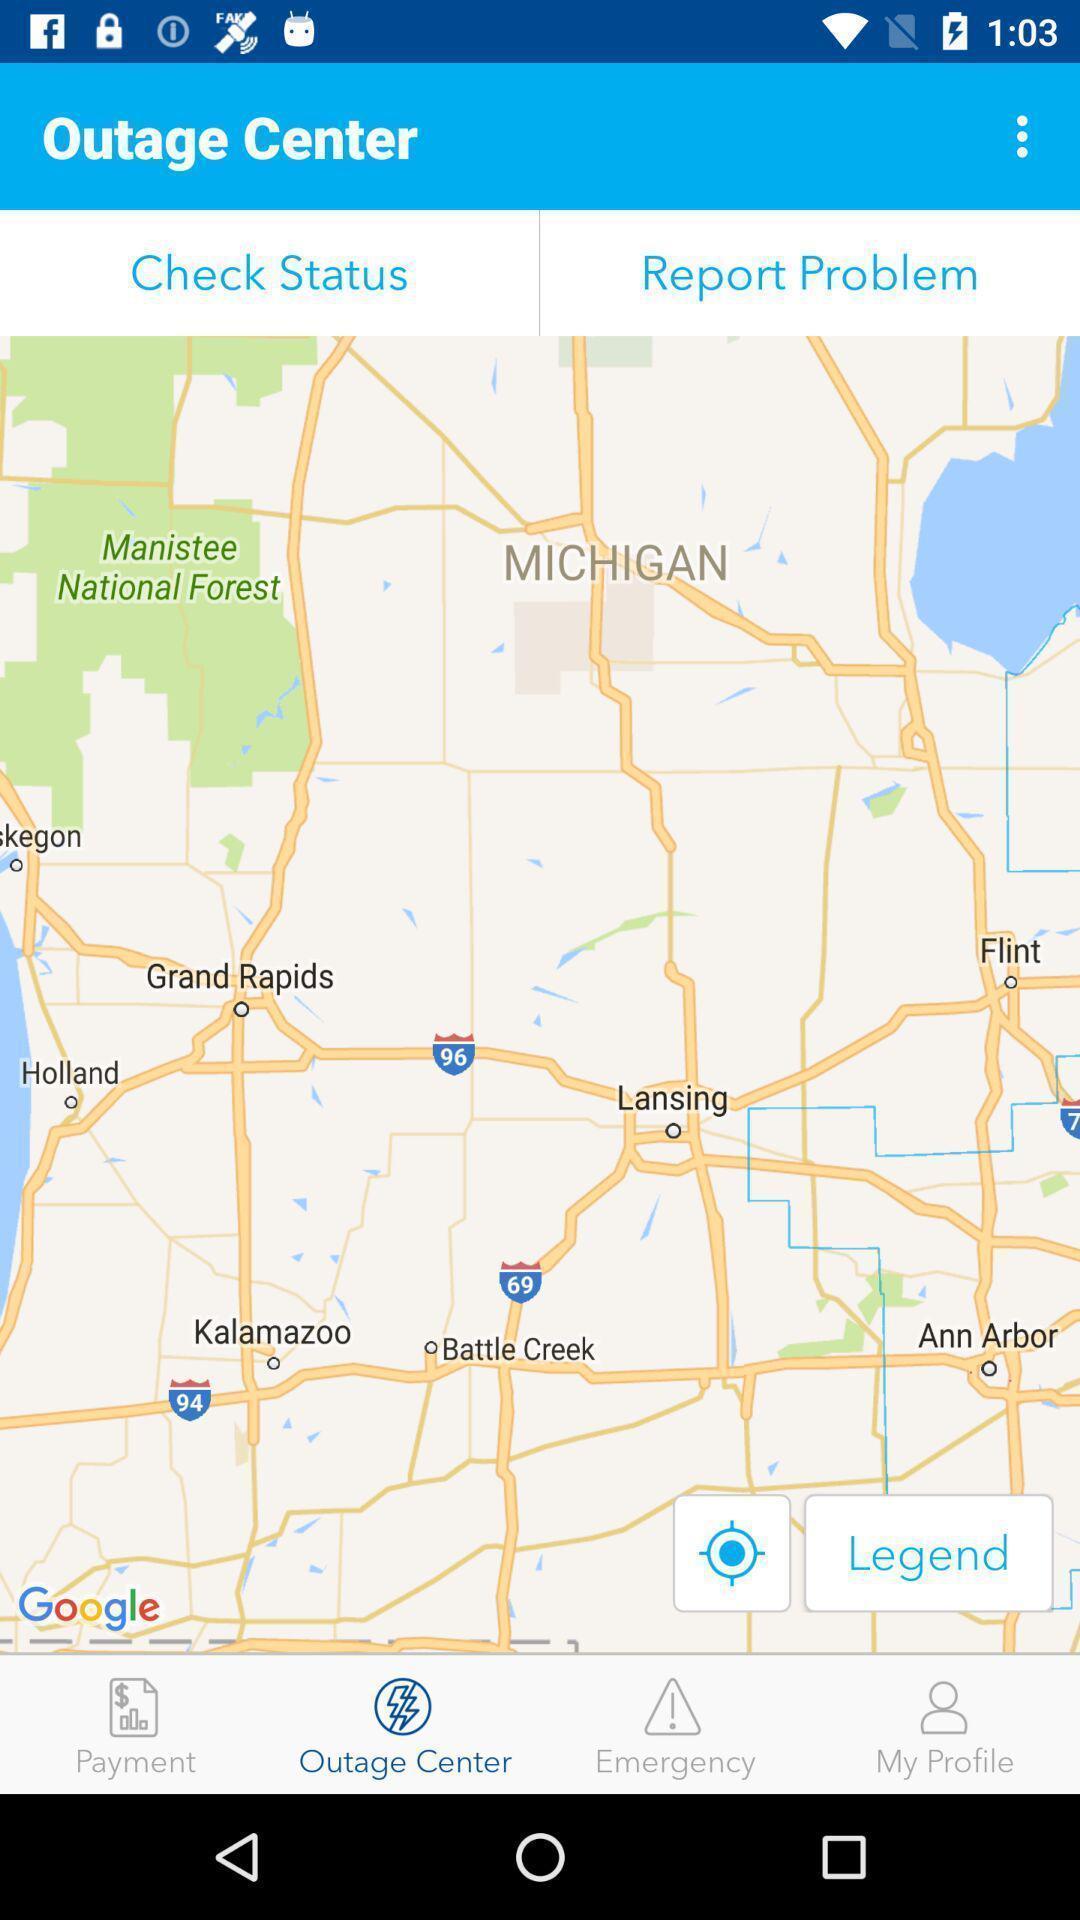Describe the visual elements of this screenshot. Screen showing outage center page. 